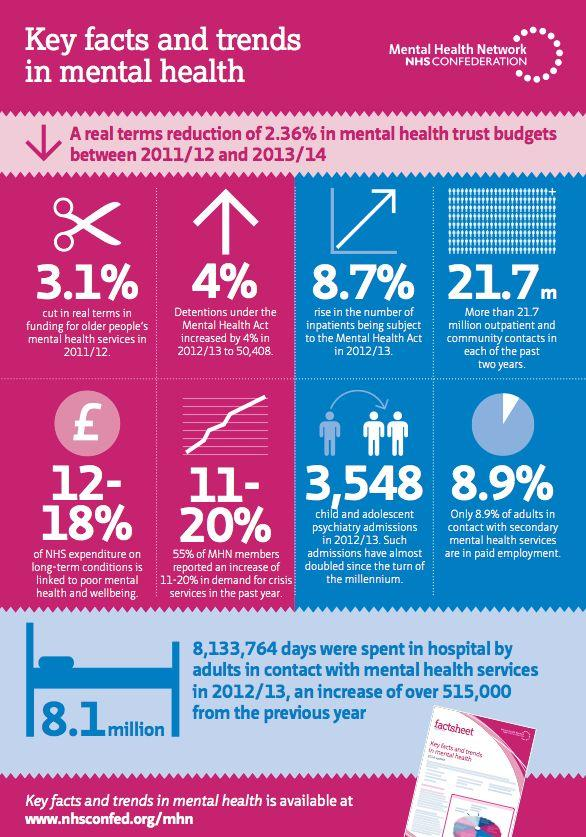Specify some key components in this picture. During the study period, there were 3,548 admissions for child and adolescent psychiatry. The number of inpatients subject to the Mental Health Act increased by 8.7% in 2012/13. In the year 2011/12, a total of 761,876 adults who were in contact with mental health services spent time in the hospital. According to NHS expenditure on long-term conditions, poor mental health and well-being contribute to approximately 12-18% of the total spending. 